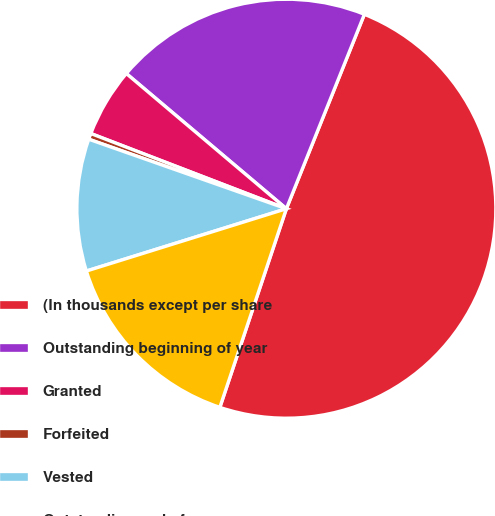Convert chart to OTSL. <chart><loc_0><loc_0><loc_500><loc_500><pie_chart><fcel>(In thousands except per share<fcel>Outstanding beginning of year<fcel>Granted<fcel>Forfeited<fcel>Vested<fcel>Outstanding end of year<nl><fcel>49.07%<fcel>19.91%<fcel>5.32%<fcel>0.46%<fcel>10.19%<fcel>15.05%<nl></chart> 